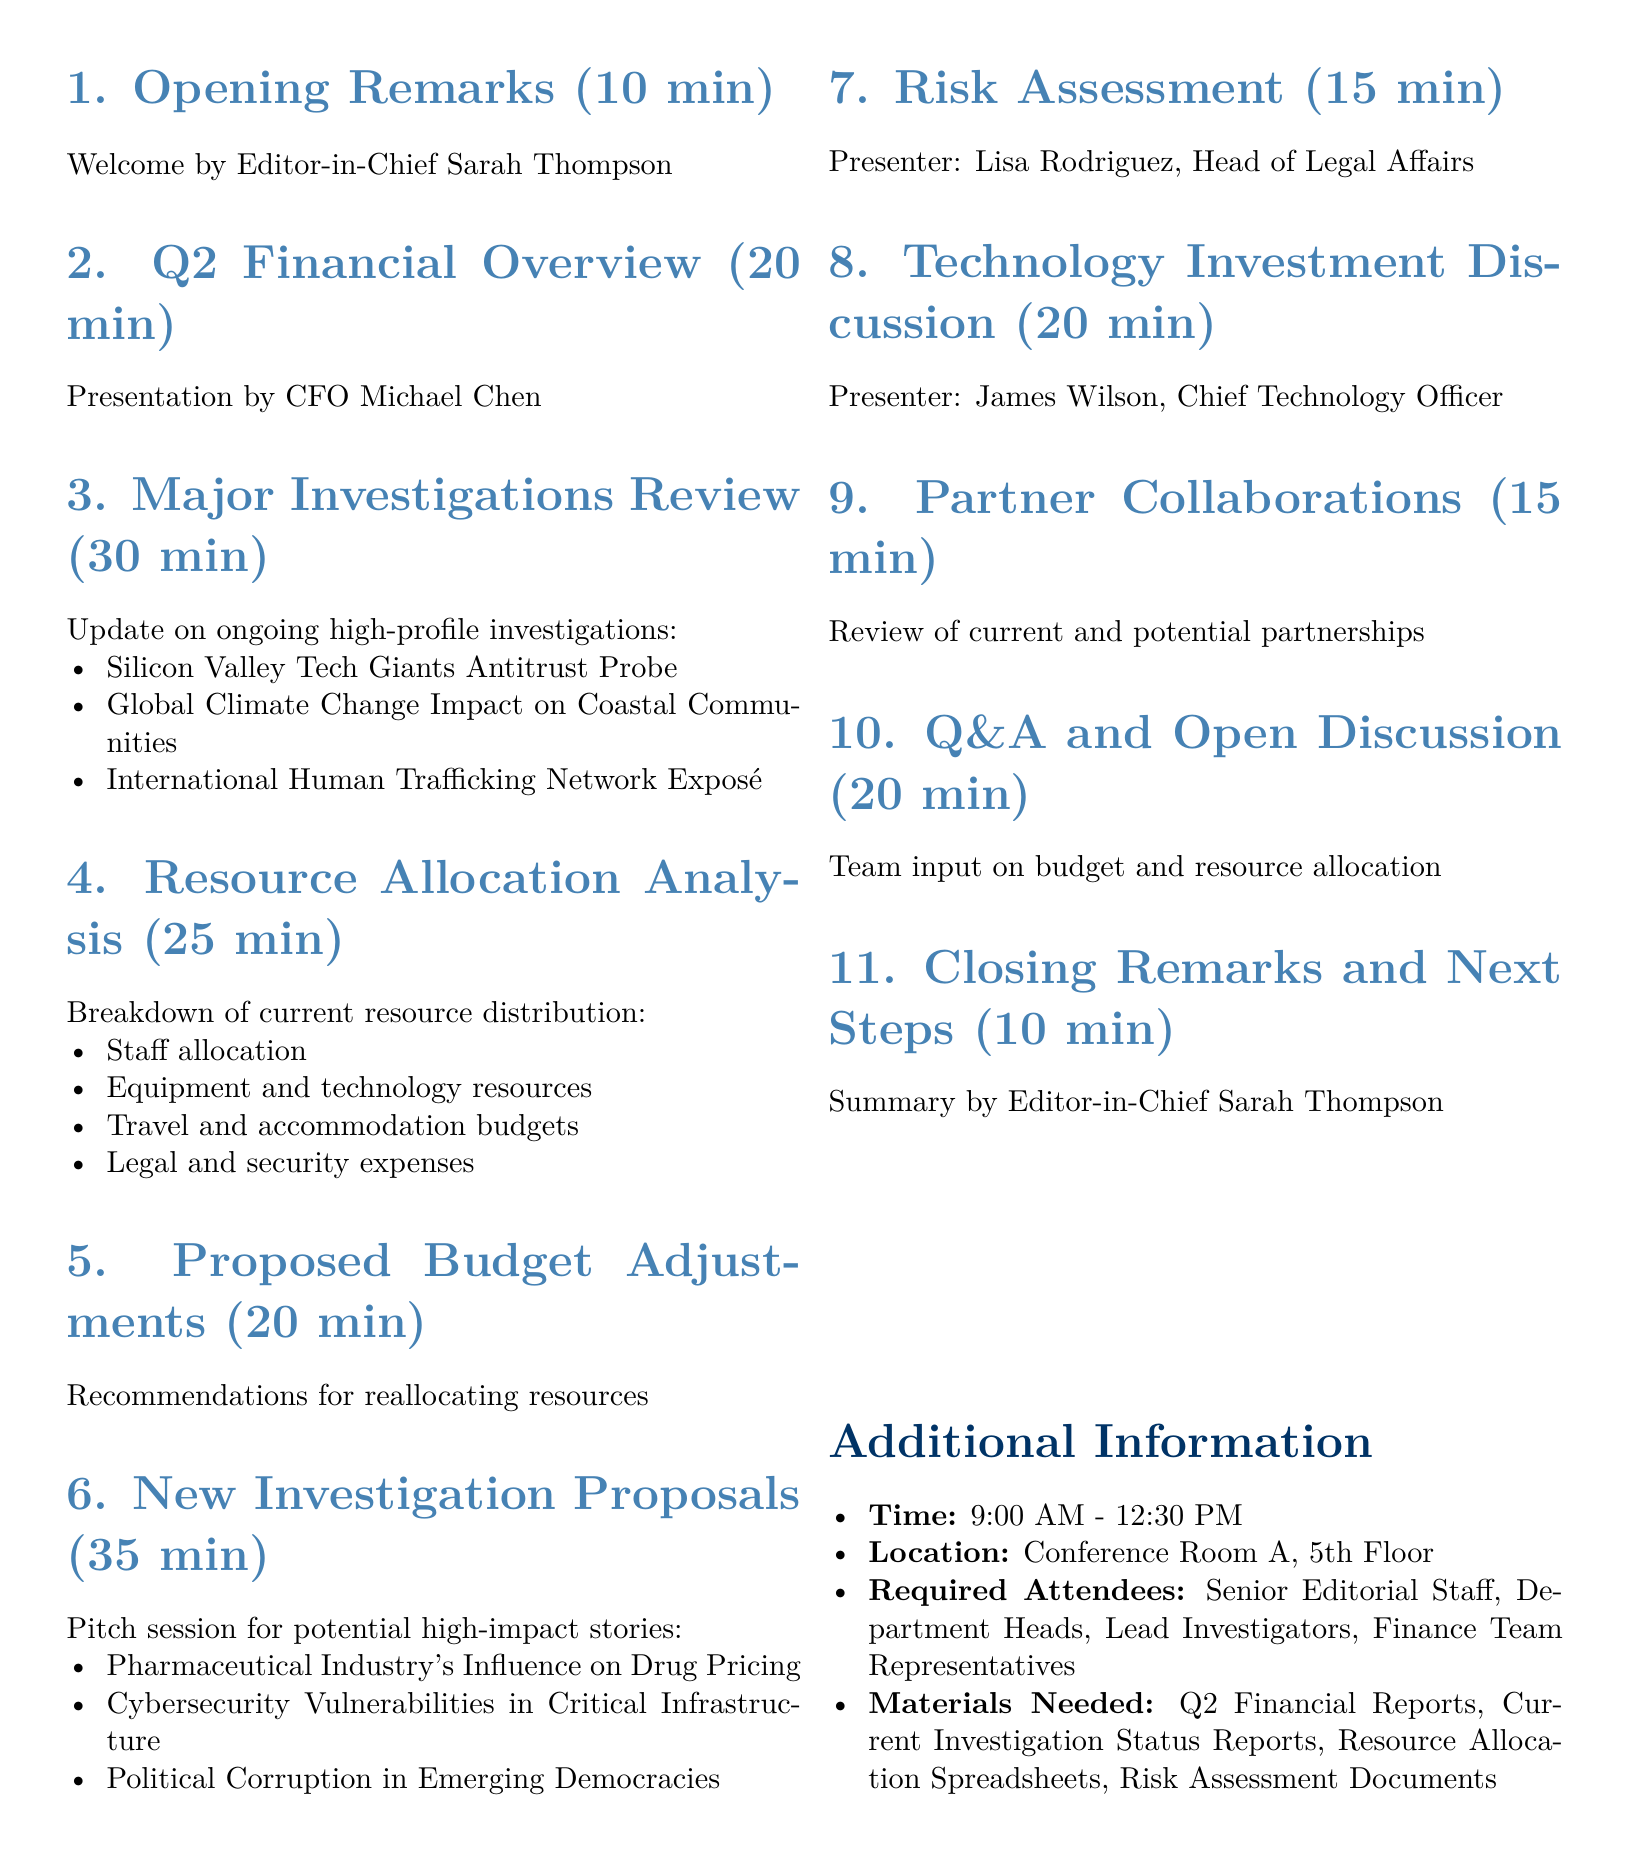What is the date of the meeting? The meeting is scheduled for July 15, 2023.
Answer: July 15, 2023 Who presents the Q2 Financial Overview? The Q2 Financial Overview is presented by CFO Michael Chen.
Answer: CFO Michael Chen What is the duration of the Major Investigations Review? The Major Investigations Review lasts for 30 minutes.
Answer: 30 minutes How many proposed new investigation stories are there? There are three proposed new investigation stories.
Answer: Three What is the title of the first ongoing high-profile investigation? The title of the first ongoing investigation is the Silicon Valley Tech Giants Antitrust Probe.
Answer: Silicon Valley Tech Giants Antitrust Probe Who is responsible for the Risk Assessment? The Risk Assessment is presented by Lisa Rodriguez, Head of Legal Affairs.
Answer: Lisa Rodriguez What is listed as a material needed for the meeting? Current Investigation Status Reports is one of the materials needed.
Answer: Current Investigation Status Reports What time does the meeting start? The meeting starts at 9:00 AM.
Answer: 9:00 AM What is the last item on the agenda? The last item on the agenda is Closing Remarks and Next Steps.
Answer: Closing Remarks and Next Steps 